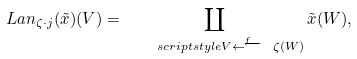Convert formula to latex. <formula><loc_0><loc_0><loc_500><loc_500>L a n _ { \zeta \cdot j } ( \tilde { x } ) ( V ) = \coprod _ { \quad s c r i p t s t y l e V \stackrel { f } { \longleftarrow } \ \zeta ( W ) } \tilde { x } ( W ) ,</formula> 